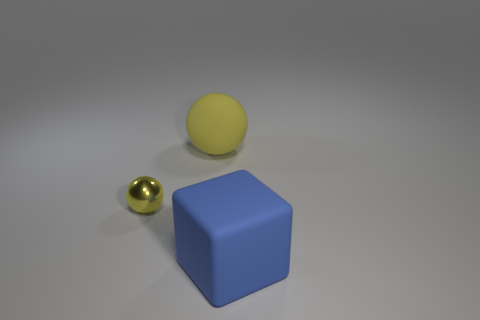Is there any other thing that is the same material as the small yellow object?
Offer a terse response. No. What size is the rubber object in front of the big matte thing that is behind the large thing that is right of the rubber ball?
Give a very brief answer. Large. What number of blue things are either rubber blocks or tiny metallic balls?
Offer a terse response. 1. There is a yellow object to the left of the yellow rubber thing; is its shape the same as the large yellow matte thing?
Keep it short and to the point. Yes. Are there more large matte things behind the yellow metal object than small red shiny objects?
Your response must be concise. Yes. What number of yellow rubber spheres have the same size as the blue block?
Provide a short and direct response. 1. The other metal ball that is the same color as the large sphere is what size?
Your answer should be compact. Small. What number of things are large blue blocks or matte objects left of the blue rubber thing?
Your answer should be compact. 2. What color is the object that is in front of the large yellow rubber thing and to the left of the large blue matte thing?
Provide a succinct answer. Yellow. Is the size of the yellow rubber sphere the same as the matte block?
Ensure brevity in your answer.  Yes. 